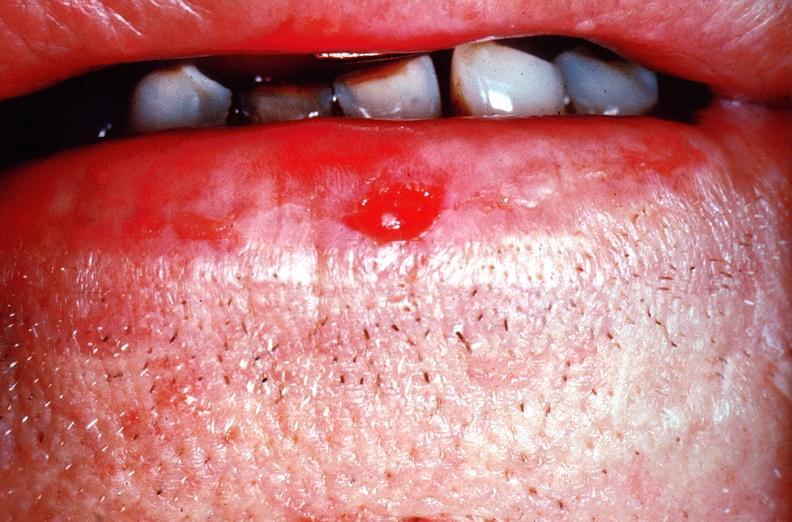where is this?
Answer the question using a single word or phrase. Skin 